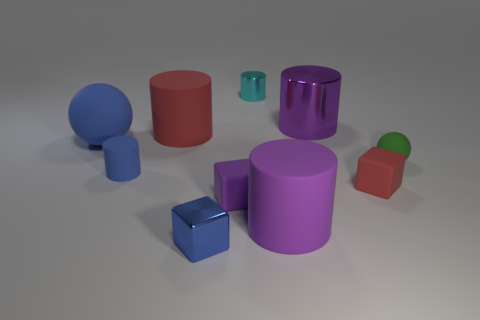How do the shadows in the image inform us about the lighting? The shadows cast by the objects indicate a single light source positioned to the top-left of the scene. The consistent direction and length of the shadows suggest the light source is not very near, providing a soft delineation of shadow edges. This setup creates a fairly neutral and evenly lit environment, allowing the colors and textures of the objects to be distinct and observable. 